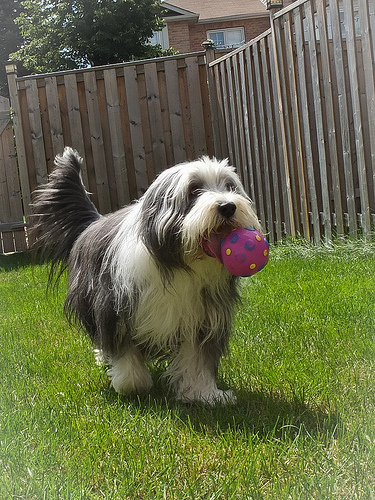<image>
Is the wooden fence to the left of the dog? Yes. From this viewpoint, the wooden fence is positioned to the left side relative to the dog. 